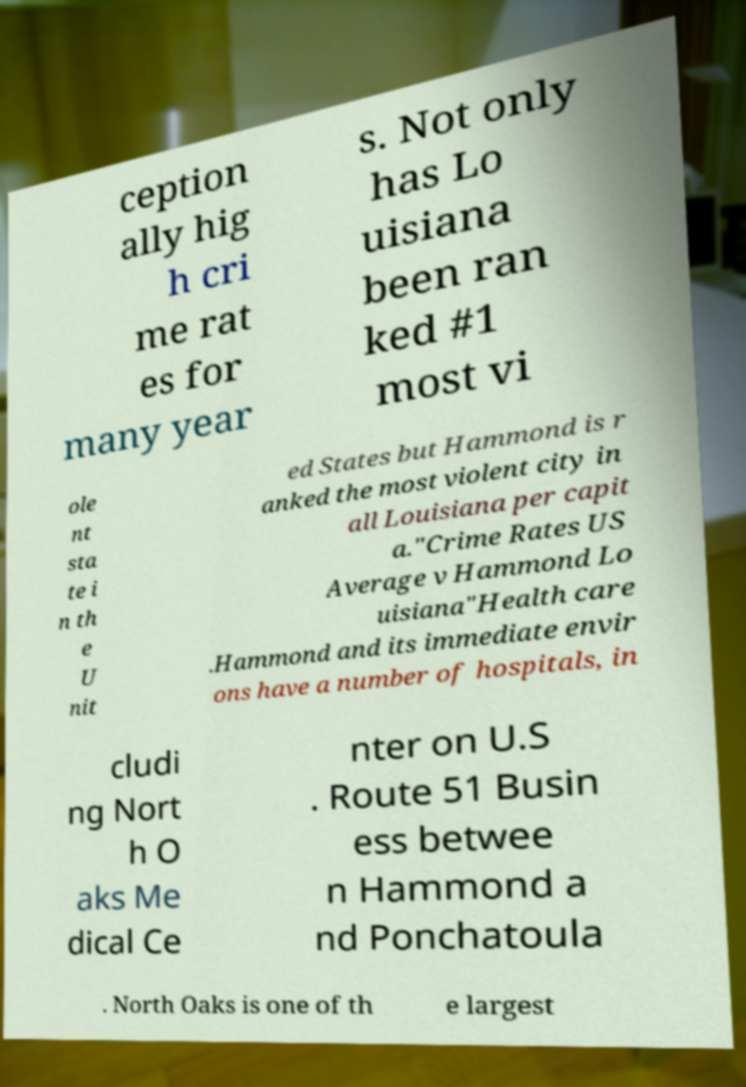There's text embedded in this image that I need extracted. Can you transcribe it verbatim? ception ally hig h cri me rat es for many year s. Not only has Lo uisiana been ran ked #1 most vi ole nt sta te i n th e U nit ed States but Hammond is r anked the most violent city in all Louisiana per capit a."Crime Rates US Average v Hammond Lo uisiana"Health care .Hammond and its immediate envir ons have a number of hospitals, in cludi ng Nort h O aks Me dical Ce nter on U.S . Route 51 Busin ess betwee n Hammond a nd Ponchatoula . North Oaks is one of th e largest 